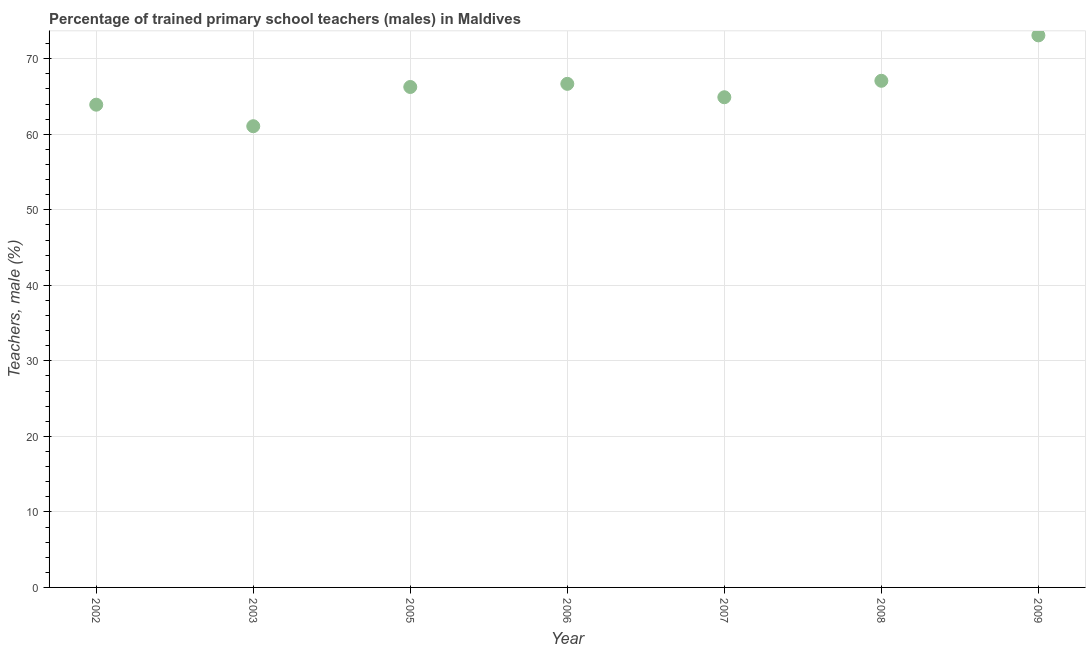What is the percentage of trained male teachers in 2007?
Your answer should be very brief. 64.91. Across all years, what is the maximum percentage of trained male teachers?
Keep it short and to the point. 73.1. Across all years, what is the minimum percentage of trained male teachers?
Your answer should be compact. 61.07. In which year was the percentage of trained male teachers minimum?
Your answer should be compact. 2003. What is the sum of the percentage of trained male teachers?
Offer a very short reply. 463.03. What is the difference between the percentage of trained male teachers in 2003 and 2006?
Provide a succinct answer. -5.61. What is the average percentage of trained male teachers per year?
Your response must be concise. 66.15. What is the median percentage of trained male teachers?
Your answer should be compact. 66.27. Do a majority of the years between 2007 and 2005 (inclusive) have percentage of trained male teachers greater than 38 %?
Ensure brevity in your answer.  No. What is the ratio of the percentage of trained male teachers in 2002 to that in 2007?
Ensure brevity in your answer.  0.98. What is the difference between the highest and the second highest percentage of trained male teachers?
Your answer should be compact. 6.02. What is the difference between the highest and the lowest percentage of trained male teachers?
Your answer should be very brief. 12.03. In how many years, is the percentage of trained male teachers greater than the average percentage of trained male teachers taken over all years?
Offer a very short reply. 4. Does the percentage of trained male teachers monotonically increase over the years?
Offer a very short reply. No. How many years are there in the graph?
Make the answer very short. 7. What is the title of the graph?
Make the answer very short. Percentage of trained primary school teachers (males) in Maldives. What is the label or title of the Y-axis?
Your response must be concise. Teachers, male (%). What is the Teachers, male (%) in 2002?
Ensure brevity in your answer.  63.92. What is the Teachers, male (%) in 2003?
Make the answer very short. 61.07. What is the Teachers, male (%) in 2005?
Provide a succinct answer. 66.27. What is the Teachers, male (%) in 2006?
Your answer should be very brief. 66.68. What is the Teachers, male (%) in 2007?
Your answer should be very brief. 64.91. What is the Teachers, male (%) in 2008?
Provide a succinct answer. 67.08. What is the Teachers, male (%) in 2009?
Provide a succinct answer. 73.1. What is the difference between the Teachers, male (%) in 2002 and 2003?
Your answer should be very brief. 2.85. What is the difference between the Teachers, male (%) in 2002 and 2005?
Keep it short and to the point. -2.34. What is the difference between the Teachers, male (%) in 2002 and 2006?
Offer a very short reply. -2.76. What is the difference between the Teachers, male (%) in 2002 and 2007?
Offer a very short reply. -0.99. What is the difference between the Teachers, male (%) in 2002 and 2008?
Offer a very short reply. -3.16. What is the difference between the Teachers, male (%) in 2002 and 2009?
Make the answer very short. -9.18. What is the difference between the Teachers, male (%) in 2003 and 2005?
Give a very brief answer. -5.19. What is the difference between the Teachers, male (%) in 2003 and 2006?
Offer a very short reply. -5.61. What is the difference between the Teachers, male (%) in 2003 and 2007?
Make the answer very short. -3.84. What is the difference between the Teachers, male (%) in 2003 and 2008?
Make the answer very short. -6.01. What is the difference between the Teachers, male (%) in 2003 and 2009?
Give a very brief answer. -12.03. What is the difference between the Teachers, male (%) in 2005 and 2006?
Give a very brief answer. -0.42. What is the difference between the Teachers, male (%) in 2005 and 2007?
Your response must be concise. 1.36. What is the difference between the Teachers, male (%) in 2005 and 2008?
Offer a very short reply. -0.82. What is the difference between the Teachers, male (%) in 2005 and 2009?
Give a very brief answer. -6.83. What is the difference between the Teachers, male (%) in 2006 and 2007?
Provide a succinct answer. 1.77. What is the difference between the Teachers, male (%) in 2006 and 2008?
Your response must be concise. -0.4. What is the difference between the Teachers, male (%) in 2006 and 2009?
Provide a short and direct response. -6.42. What is the difference between the Teachers, male (%) in 2007 and 2008?
Make the answer very short. -2.18. What is the difference between the Teachers, male (%) in 2007 and 2009?
Your answer should be very brief. -8.19. What is the difference between the Teachers, male (%) in 2008 and 2009?
Ensure brevity in your answer.  -6.02. What is the ratio of the Teachers, male (%) in 2002 to that in 2003?
Your answer should be compact. 1.05. What is the ratio of the Teachers, male (%) in 2002 to that in 2007?
Your answer should be very brief. 0.98. What is the ratio of the Teachers, male (%) in 2002 to that in 2008?
Your answer should be very brief. 0.95. What is the ratio of the Teachers, male (%) in 2002 to that in 2009?
Your response must be concise. 0.87. What is the ratio of the Teachers, male (%) in 2003 to that in 2005?
Keep it short and to the point. 0.92. What is the ratio of the Teachers, male (%) in 2003 to that in 2006?
Your answer should be compact. 0.92. What is the ratio of the Teachers, male (%) in 2003 to that in 2007?
Offer a terse response. 0.94. What is the ratio of the Teachers, male (%) in 2003 to that in 2008?
Offer a terse response. 0.91. What is the ratio of the Teachers, male (%) in 2003 to that in 2009?
Keep it short and to the point. 0.83. What is the ratio of the Teachers, male (%) in 2005 to that in 2007?
Keep it short and to the point. 1.02. What is the ratio of the Teachers, male (%) in 2005 to that in 2009?
Your response must be concise. 0.91. What is the ratio of the Teachers, male (%) in 2006 to that in 2008?
Your answer should be compact. 0.99. What is the ratio of the Teachers, male (%) in 2006 to that in 2009?
Your response must be concise. 0.91. What is the ratio of the Teachers, male (%) in 2007 to that in 2009?
Offer a very short reply. 0.89. What is the ratio of the Teachers, male (%) in 2008 to that in 2009?
Keep it short and to the point. 0.92. 